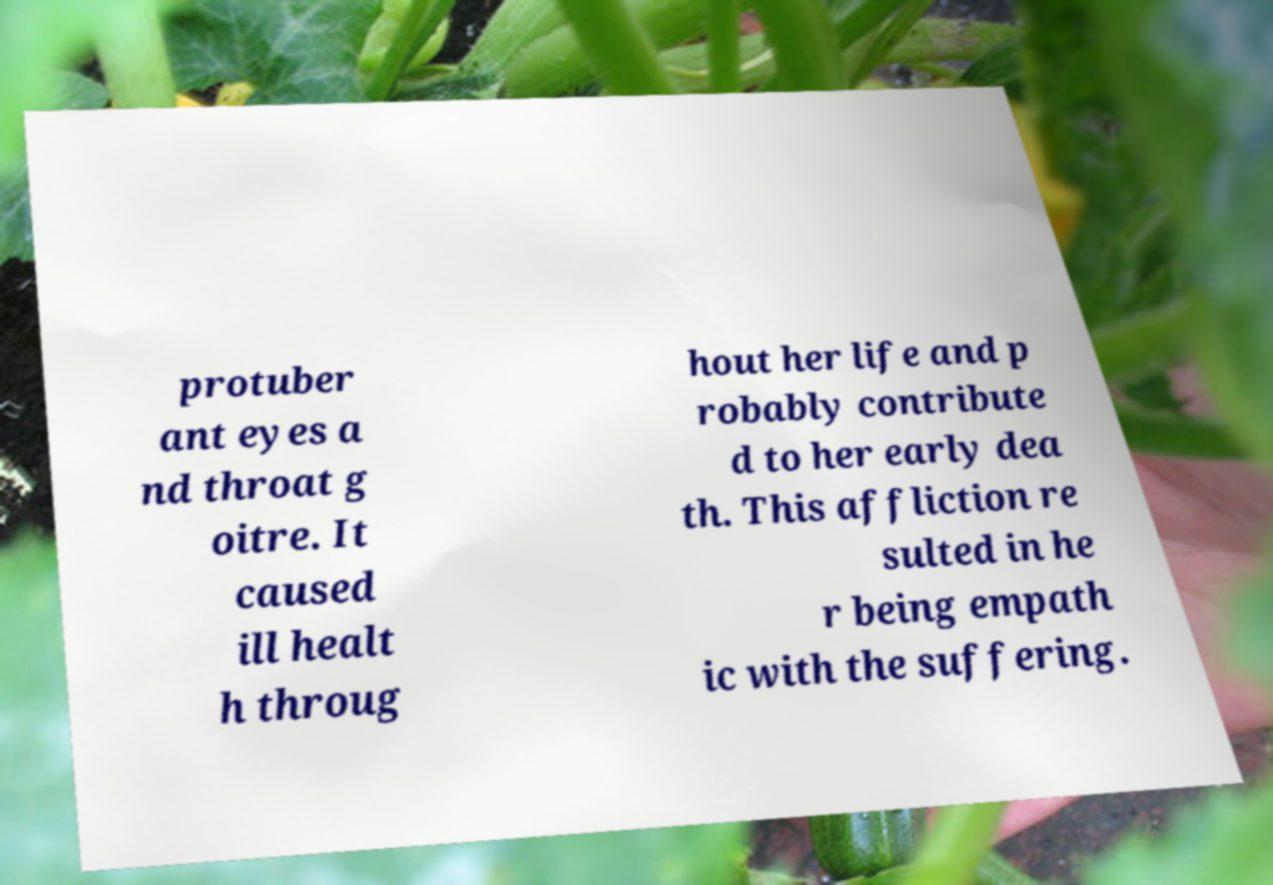Can you read and provide the text displayed in the image?This photo seems to have some interesting text. Can you extract and type it out for me? protuber ant eyes a nd throat g oitre. It caused ill healt h throug hout her life and p robably contribute d to her early dea th. This affliction re sulted in he r being empath ic with the suffering. 